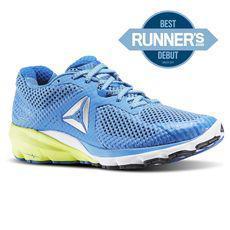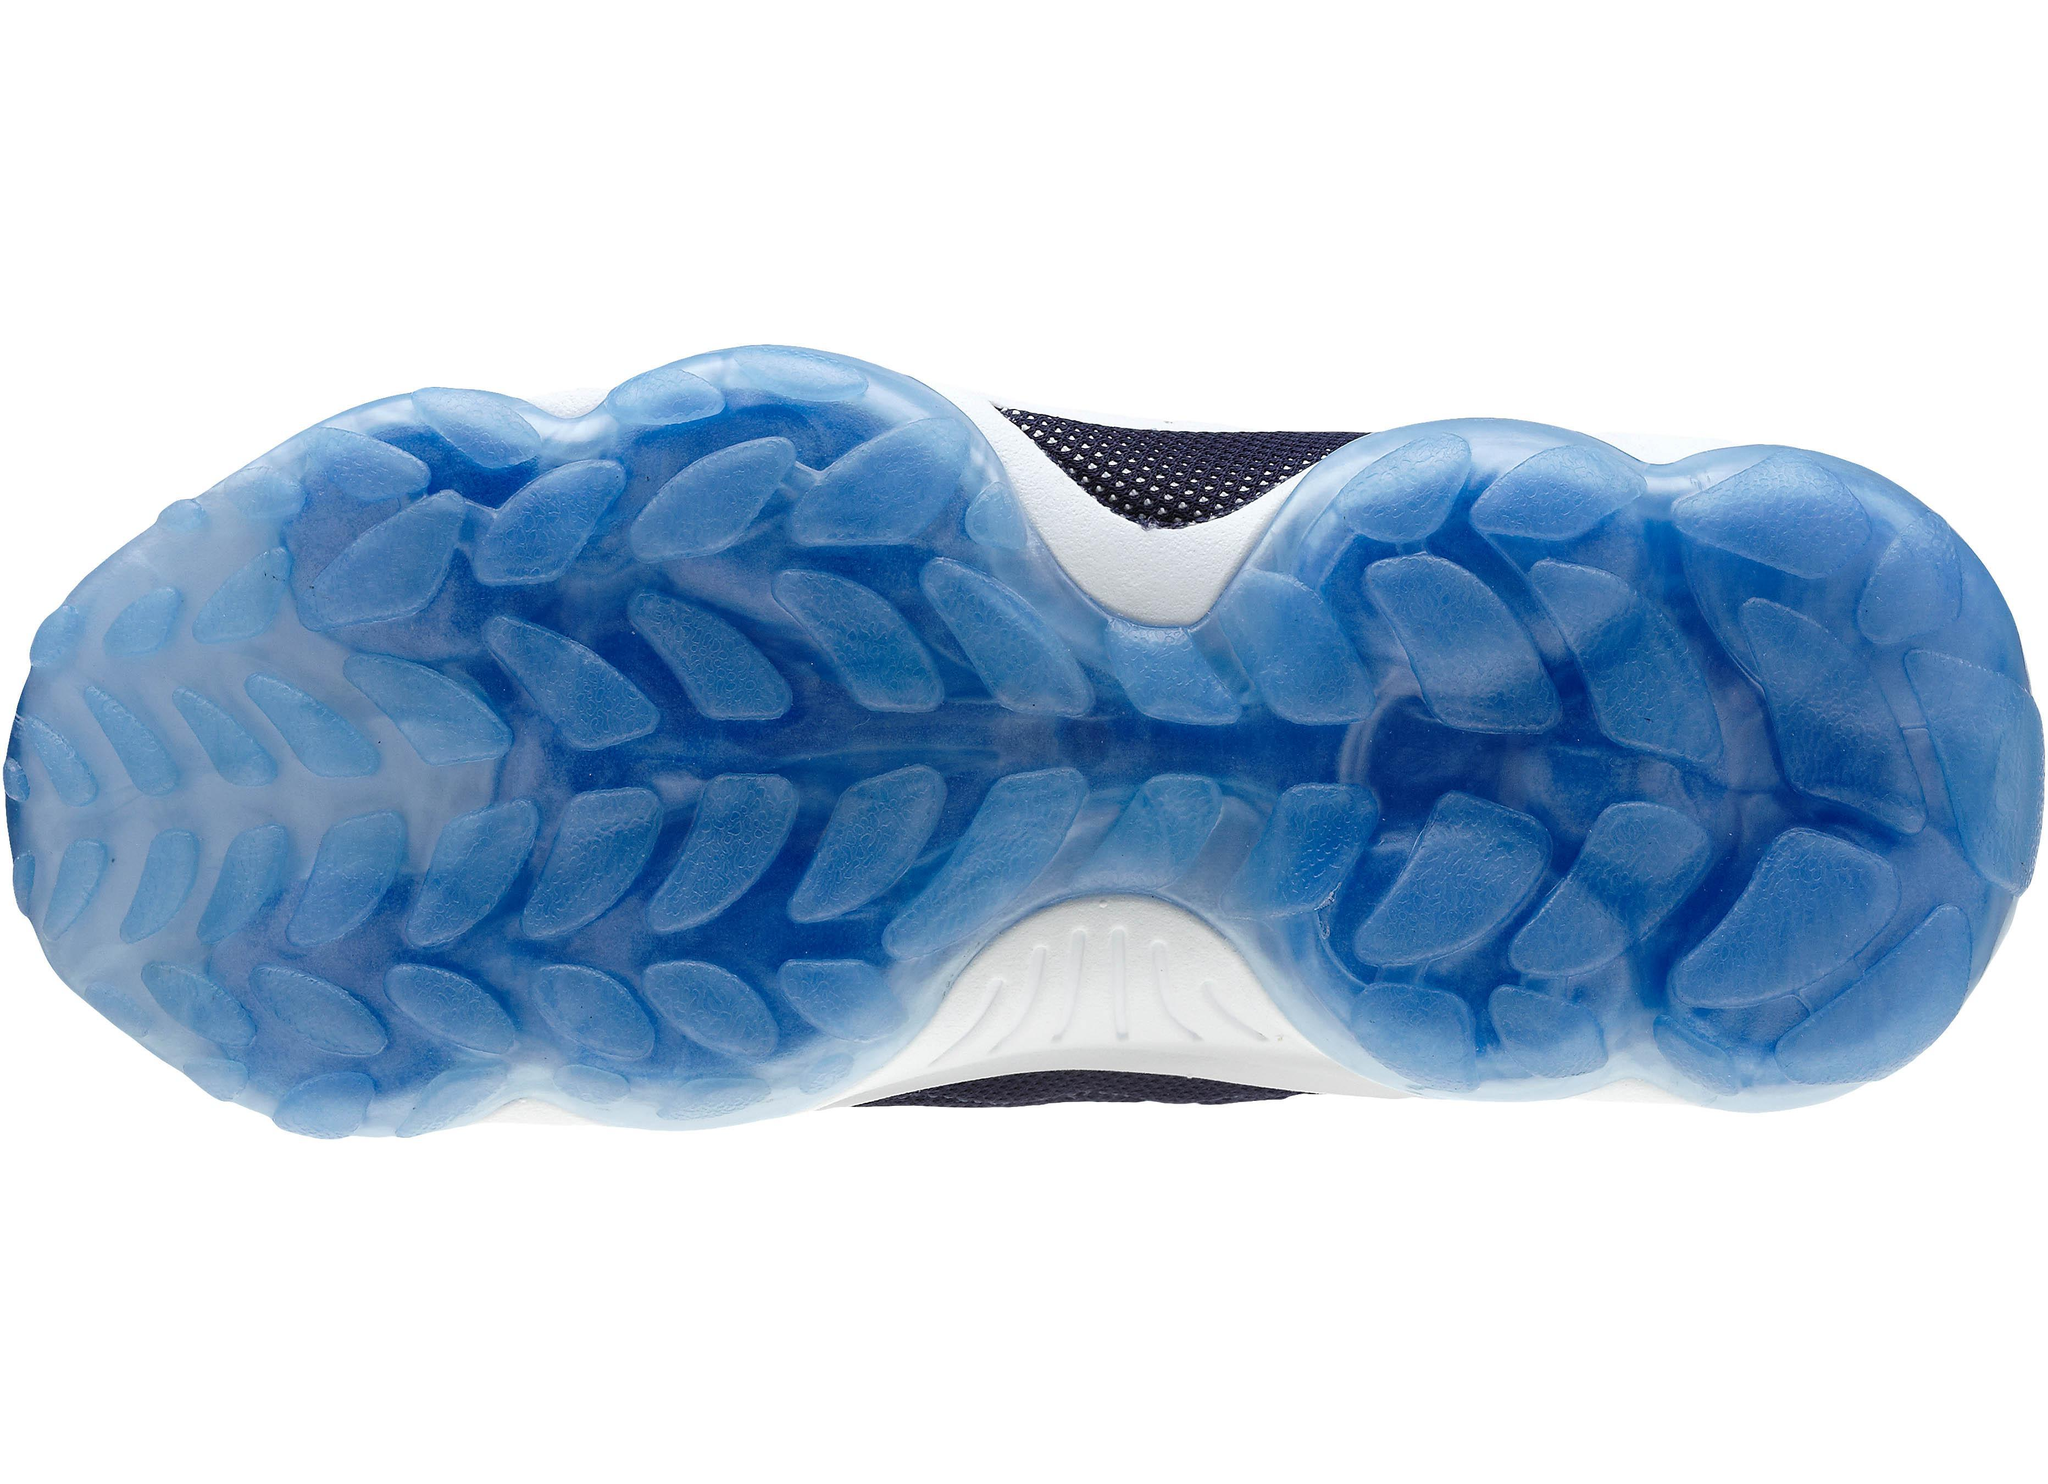The first image is the image on the left, the second image is the image on the right. Analyze the images presented: Is the assertion "The left image contains a single right-facing blue sneaker, and the right image includes a shoe sole facing the camera." valid? Answer yes or no. Yes. The first image is the image on the left, the second image is the image on the right. Considering the images on both sides, is "There are fewer than four shoes depicted." valid? Answer yes or no. Yes. 